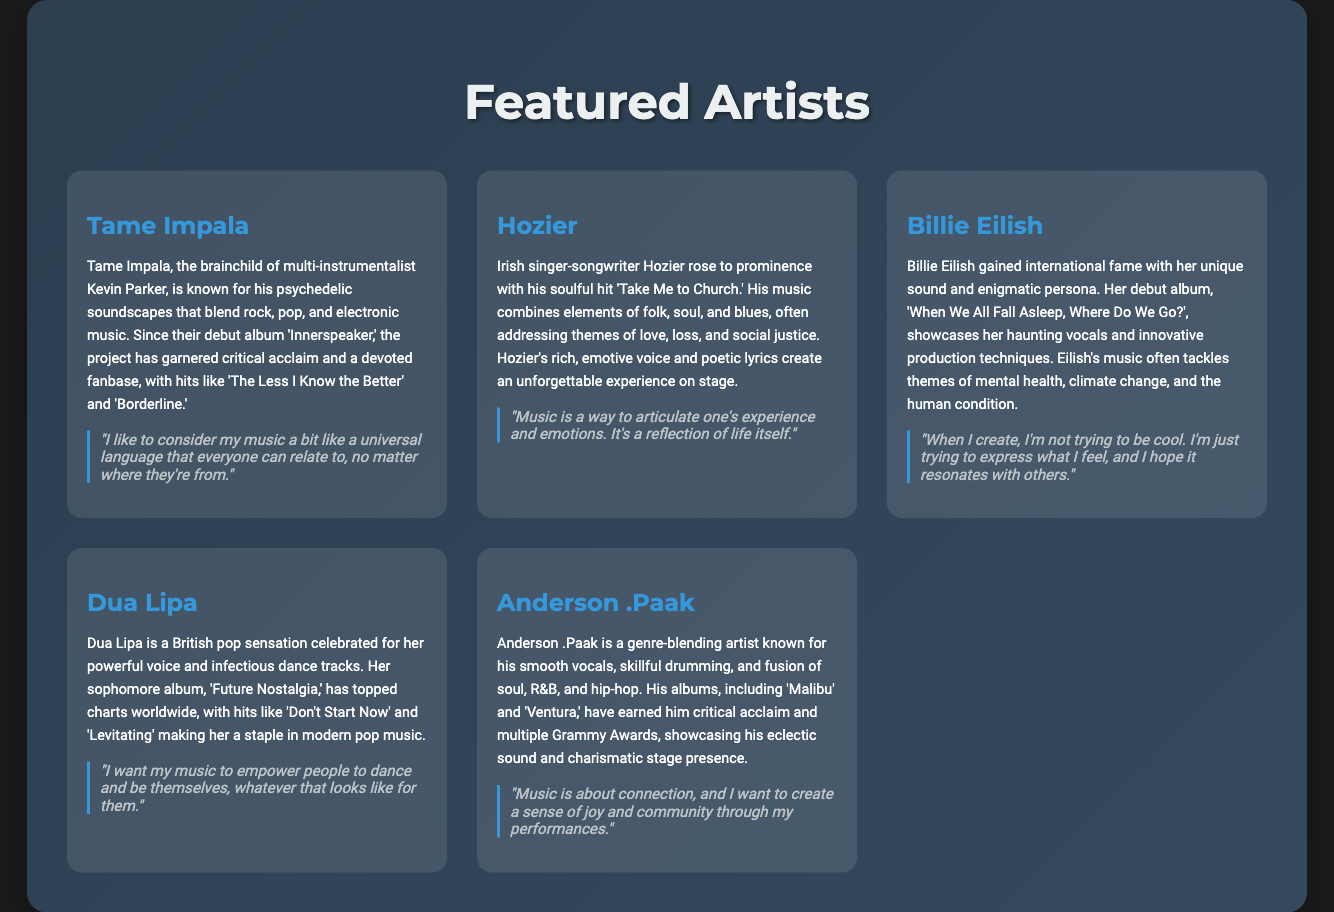What is the name of the first featured artist? The first featured artist listed in the document is Tame Impala.
Answer: Tame Impala How many artists are featured in the document? The document includes a total of five featured artists.
Answer: 5 What genre does Hozier primarily identify with? Hozier's music combines elements of folk, soul, and blues, as mentioned in his bio.
Answer: Folk, soul, blues What is Billie Eilish's debut album titled? Billie Eilish's debut album is titled "When We All Fall Asleep, Where Do We Go?".
Answer: When We All Fall Asleep, Where Do We Go? Which artist said, "I want my music to empower people to dance and be themselves"? This quote is attributed to Dua Lipa, as specified in the document.
Answer: Dua Lipa What theme does Hozier address in his music? According to the document, Hozier often addresses themes of love, loss, and social justice.
Answer: Love, loss, social justice Which artist is known for their smooth vocals and skillful drumming? The artist known for their smooth vocals and skillful drumming is Anderson .Paak.
Answer: Anderson .Paak What is the quote from Tame Impala about music? Tame Impala's quote about music is, "I like to consider my music a bit like a universal language that everyone can relate to, no matter where they're from."
Answer: "I like to consider my music a bit like a universal language that everyone can relate to, no matter where they're from." What is the background color of the document? The background color of the document is a dark shade (#1a1a1a).
Answer: Dark shade (#1a1a1a) Which album has Dua Lipa released that topped charts worldwide? Dua Lipa's album that has topped charts worldwide is "Future Nostalgia."
Answer: Future Nostalgia 